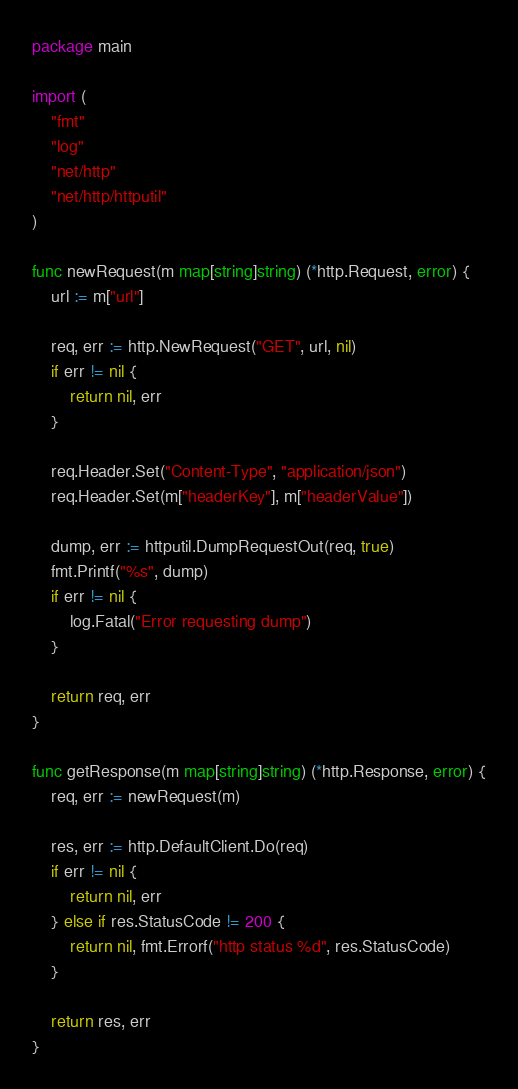<code> <loc_0><loc_0><loc_500><loc_500><_Go_>package main

import (
	"fmt"
	"log"
	"net/http"
	"net/http/httputil"
)

func newRequest(m map[string]string) (*http.Request, error) {
	url := m["url"]

	req, err := http.NewRequest("GET", url, nil)
	if err != nil {
		return nil, err
	}

	req.Header.Set("Content-Type", "application/json")
	req.Header.Set(m["headerKey"], m["headerValue"])

	dump, err := httputil.DumpRequestOut(req, true)
	fmt.Printf("%s", dump)
	if err != nil {
		log.Fatal("Error requesting dump")
	}

	return req, err
}

func getResponse(m map[string]string) (*http.Response, error) {
	req, err := newRequest(m)

	res, err := http.DefaultClient.Do(req)
	if err != nil {
		return nil, err
	} else if res.StatusCode != 200 {
		return nil, fmt.Errorf("http status %d", res.StatusCode)
	}

	return res, err
}
</code> 